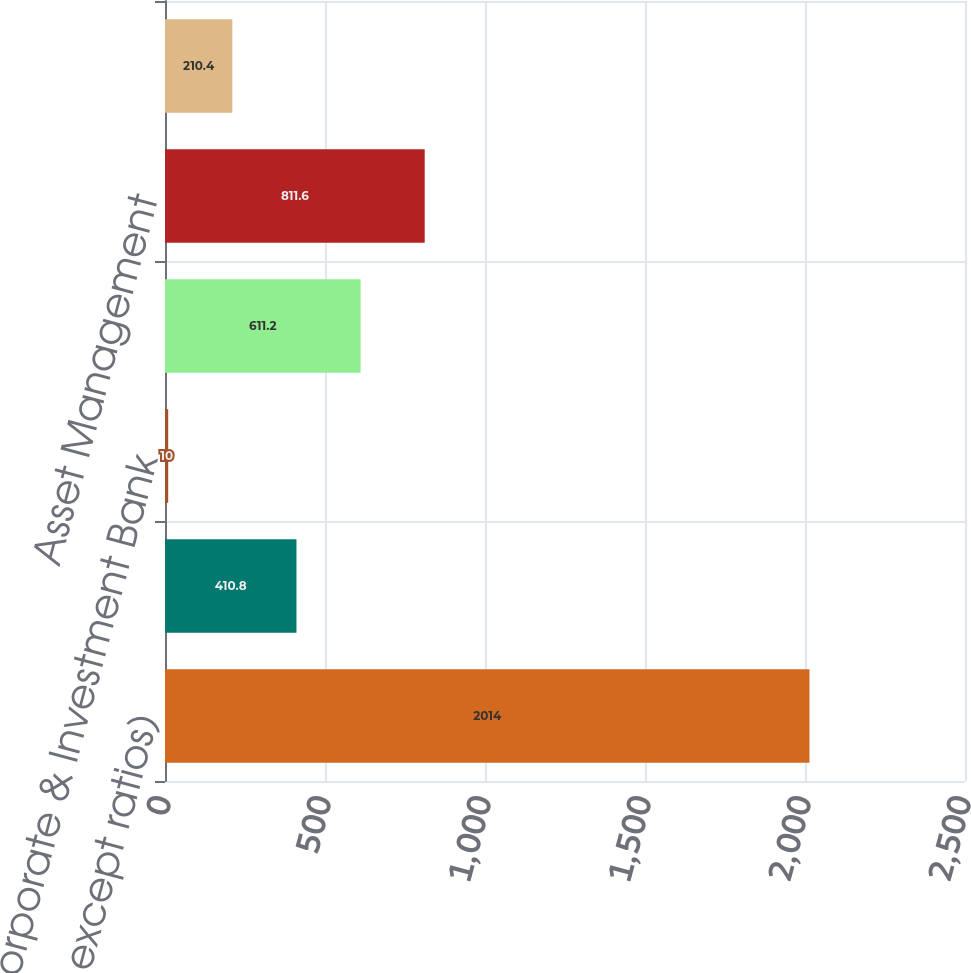Convert chart to OTSL. <chart><loc_0><loc_0><loc_500><loc_500><bar_chart><fcel>(in millions except ratios)<fcel>Consumer & Community Banking<fcel>Corporate & Investment Bank<fcel>Commercial Banking<fcel>Asset Management<fcel>Total<nl><fcel>2014<fcel>410.8<fcel>10<fcel>611.2<fcel>811.6<fcel>210.4<nl></chart> 